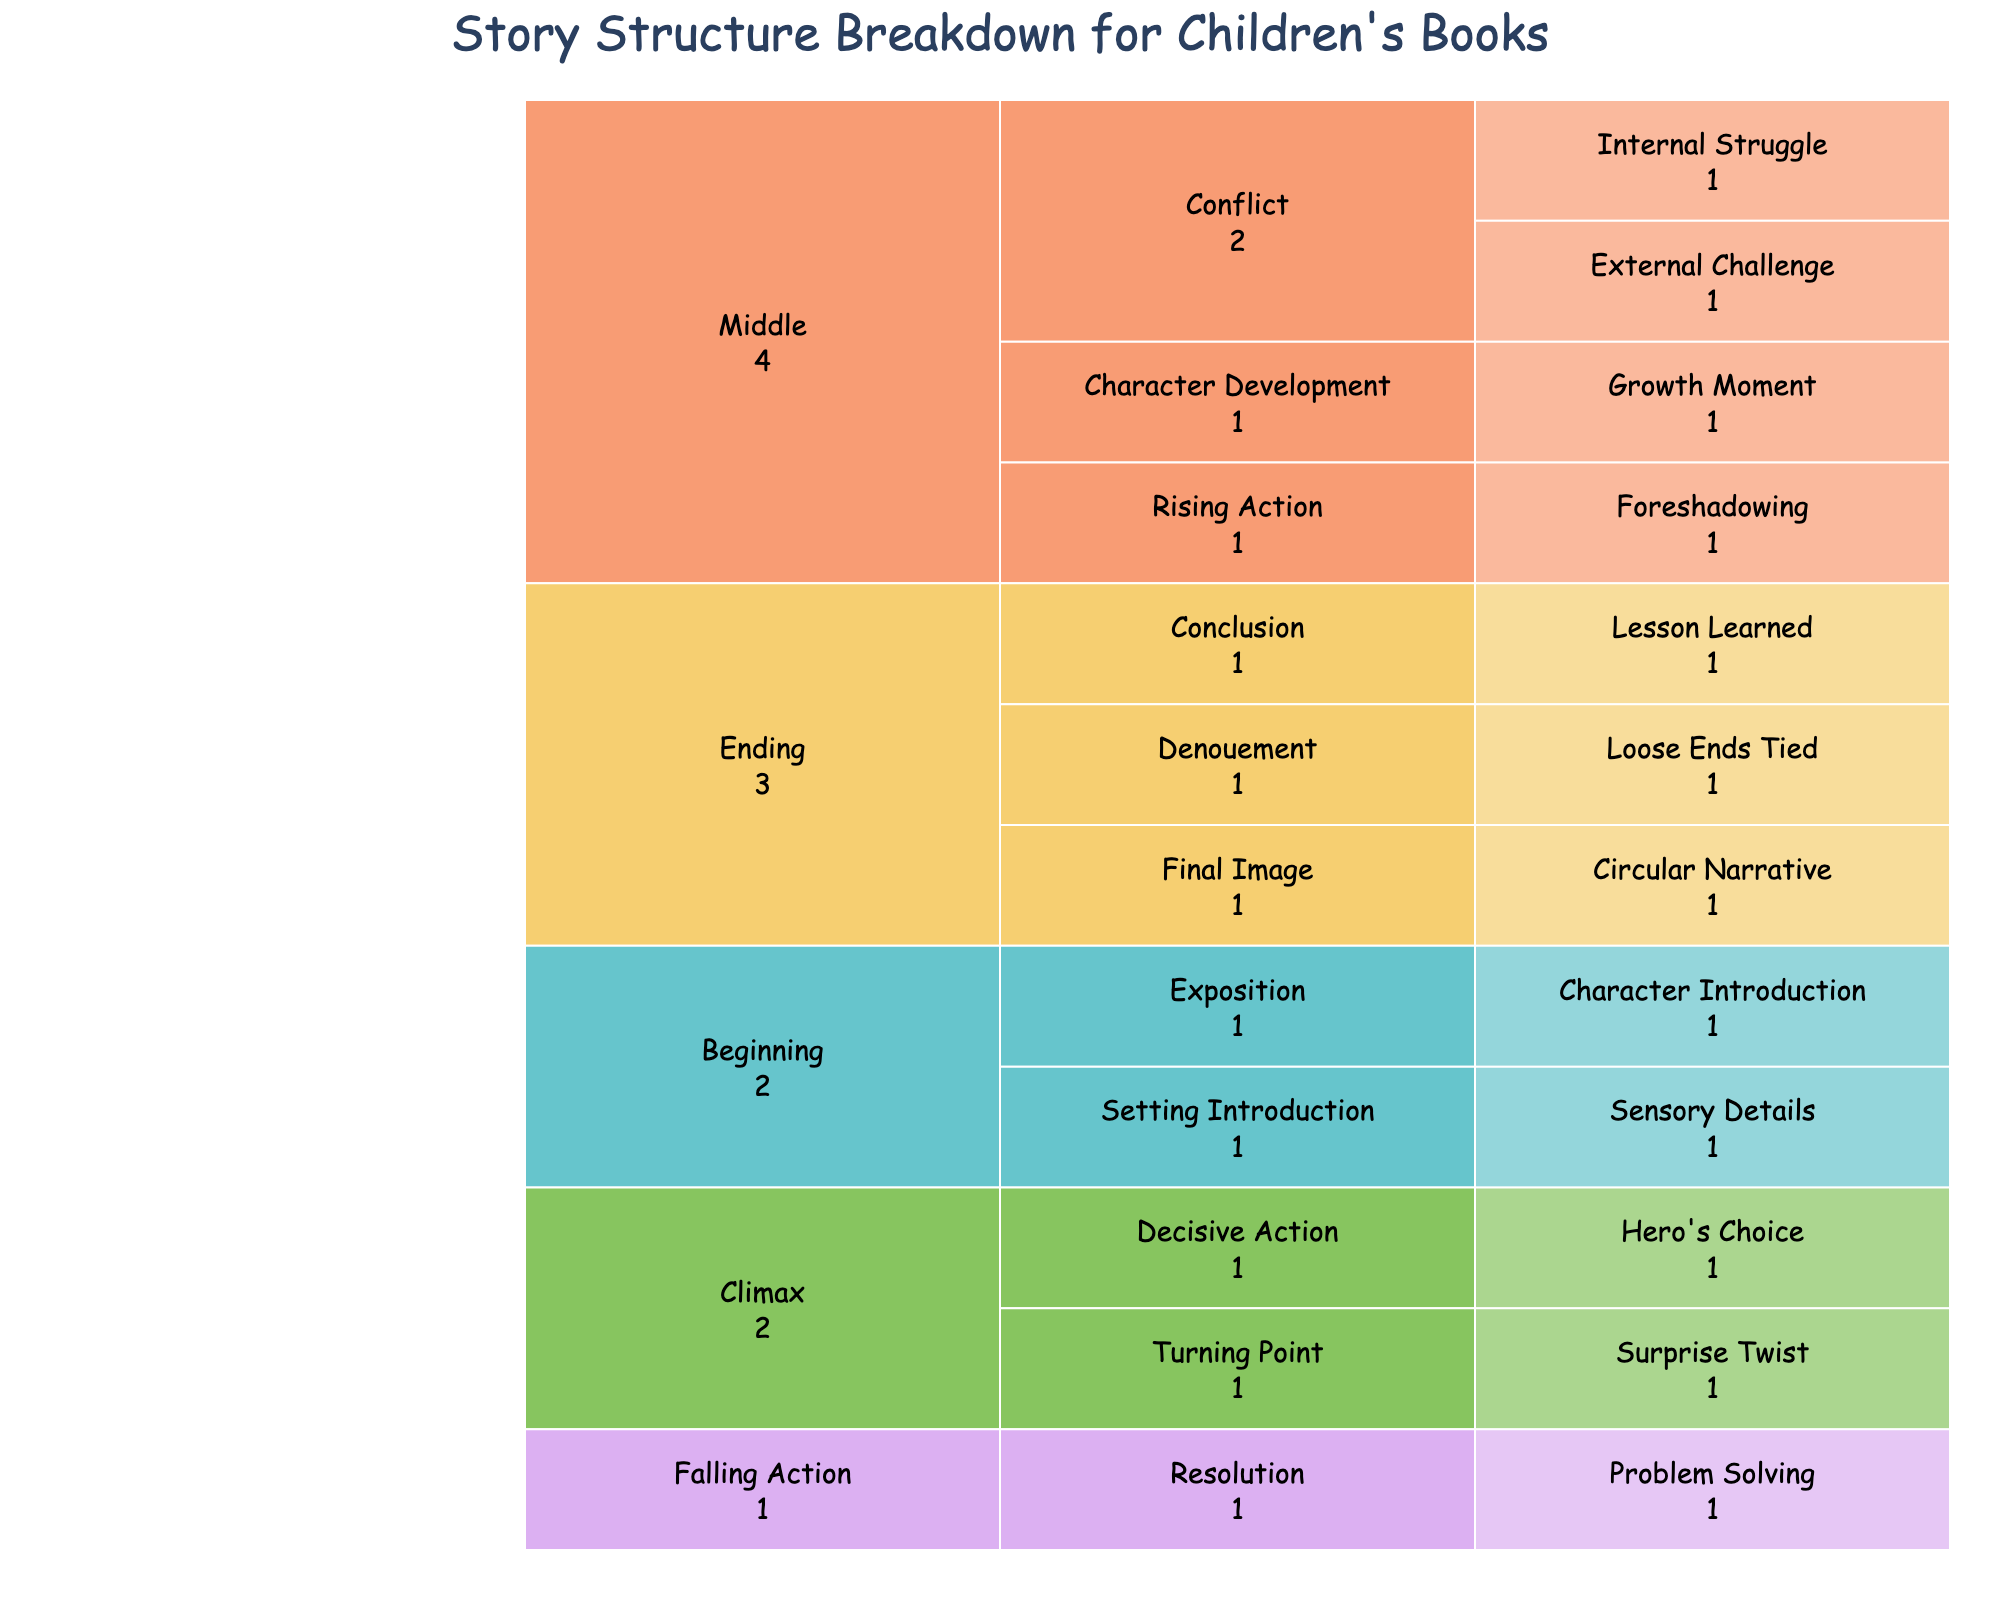What's the main title of the figure? The figure's title can be found at the top of the chart. It's usually a concise description of the chart's content. In this case, it describes the story structure of children's books.
Answer: Story Structure Breakdown for Children's Books What are the primary story structure elements shown in the chart? The primary story structure elements are the highest-level categories in the icicle chart, representing the major sections of a story. These are "Beginning," "Middle," "Climax," "Falling Action," and "Ending."
Answer: Beginning, Middle, Climax, Falling Action, Ending Which narrative device is listed under 'Setting Introduction' in the 'Beginning' section? By following the path from "Beginning" to "Setting Introduction," the narrative device listed under this category can be identified.
Answer: Sensory Details How many plot elements are detailed under the 'Middle' section? In the icicle chart, the 'Middle' section branches out to plot elements like 'Rising Action,' 'Conflict,' and 'Character Development.' Counting these plot elements will provide the answer.
Answer: Three Which plot element includes both 'Internal Struggle' and 'External Challenge' narrative devices? By following the paths in the icicle chart under the 'Middle' section, identify which plot element includes both 'Internal Struggle' and 'External Challenge'.
Answer: Conflict Under which story structure section would you find 'Hero's Choice'? By examining each story structure section and their respective branches in the icicle chart, you can locate where 'Hero's Choice' is positioned.
Answer: Climax Compare the number of narrative devices listed under 'Beginning' and 'Ending'. To answer this, count the narrative devices under both "Beginning" and "Ending" from the icicle chart and compare the totals.
Answer: Beginning has two, Ending has three Are there any narrative devices listed under 'Falling Action'? Scan the 'Falling Action' section in the icicle chart to determine whether any narrative devices are listed under it.
Answer: Yes Which plot element is associated with a 'Surprise Twist'? Locate the 'Surprise Twist' in the icicle chart, and trace it back to identify its associated plot element.
Answer: Turning Point How does the color scheme help in distinguishing different story structure sections? Notice that different story structure sections are color-coded differently. This helps in easily identifying and distinguishing between them.
Answer: Different colors for each section 